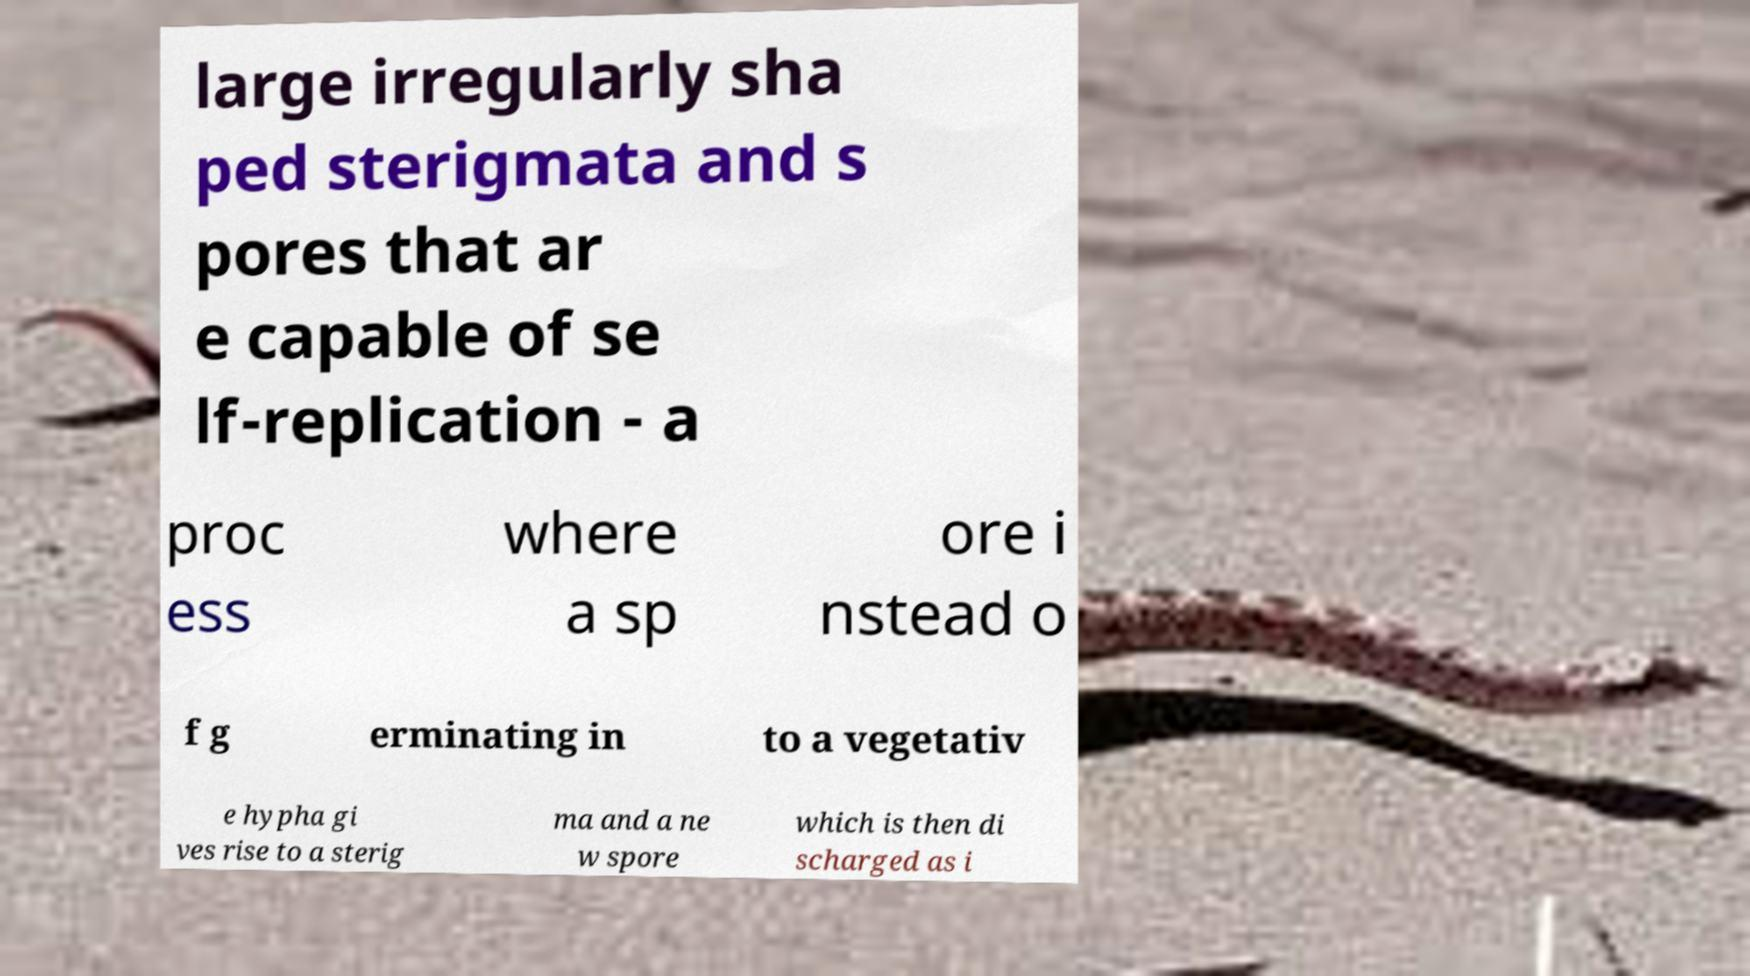For documentation purposes, I need the text within this image transcribed. Could you provide that? large irregularly sha ped sterigmata and s pores that ar e capable of se lf-replication - a proc ess where a sp ore i nstead o f g erminating in to a vegetativ e hypha gi ves rise to a sterig ma and a ne w spore which is then di scharged as i 